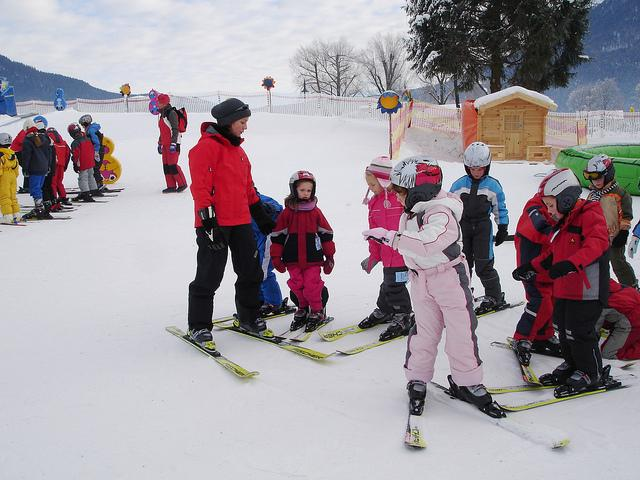Different parabolic shapes are found in? Please explain your reasoning. snowblades. The snowblades have varying shapes. 